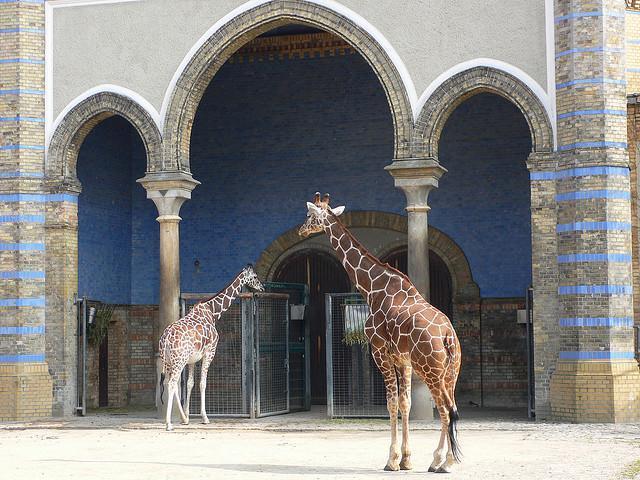How many giraffes are in the picture?
Give a very brief answer. 2. 